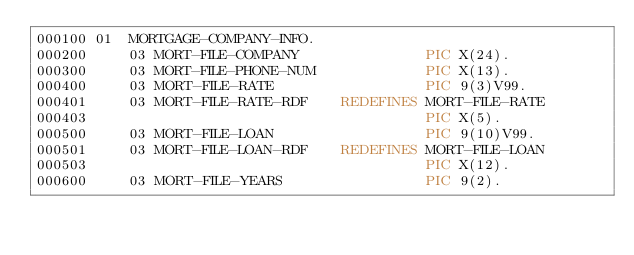<code> <loc_0><loc_0><loc_500><loc_500><_COBOL_>000100 01  MORTGAGE-COMPANY-INFO.
000200     03 MORT-FILE-COMPANY               PIC X(24).
000300     03 MORT-FILE-PHONE-NUM             PIC X(13).
000400     03 MORT-FILE-RATE                  PIC 9(3)V99.
000401     03 MORT-FILE-RATE-RDF    REDEFINES MORT-FILE-RATE
000403                                        PIC X(5).
000500     03 MORT-FILE-LOAN                  PIC 9(10)V99.
000501     03 MORT-FILE-LOAN-RDF    REDEFINES MORT-FILE-LOAN
000503                                        PIC X(12).
000600     03 MORT-FILE-YEARS                 PIC 9(2).
</code> 